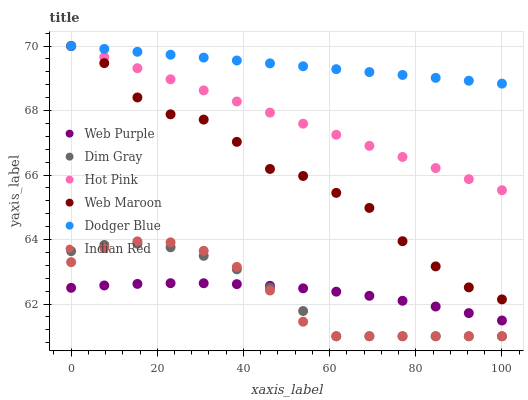Does Indian Red have the minimum area under the curve?
Answer yes or no. Yes. Does Dodger Blue have the maximum area under the curve?
Answer yes or no. Yes. Does Hot Pink have the minimum area under the curve?
Answer yes or no. No. Does Hot Pink have the maximum area under the curve?
Answer yes or no. No. Is Dodger Blue the smoothest?
Answer yes or no. Yes. Is Web Maroon the roughest?
Answer yes or no. Yes. Is Hot Pink the smoothest?
Answer yes or no. No. Is Hot Pink the roughest?
Answer yes or no. No. Does Dim Gray have the lowest value?
Answer yes or no. Yes. Does Hot Pink have the lowest value?
Answer yes or no. No. Does Dodger Blue have the highest value?
Answer yes or no. Yes. Does Web Purple have the highest value?
Answer yes or no. No. Is Web Purple less than Dodger Blue?
Answer yes or no. Yes. Is Dodger Blue greater than Dim Gray?
Answer yes or no. Yes. Does Web Purple intersect Dim Gray?
Answer yes or no. Yes. Is Web Purple less than Dim Gray?
Answer yes or no. No. Is Web Purple greater than Dim Gray?
Answer yes or no. No. Does Web Purple intersect Dodger Blue?
Answer yes or no. No. 